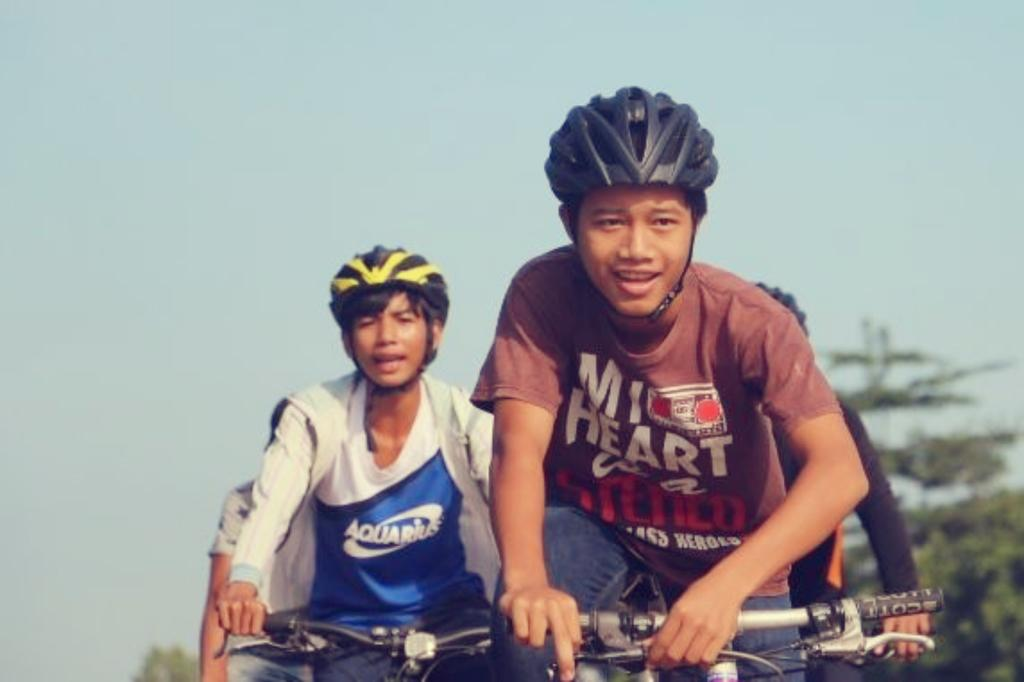Who or what can be seen in the image? There are people in the image. What are the people doing in the image? The people are riding bicycles. What can be seen in the background of the image? There are trees and the sky visible in the background of the image. What type of roof can be seen on the bicycles in the image? There are no roofs present on the bicycles in the image, as bicycles do not have roofs. 